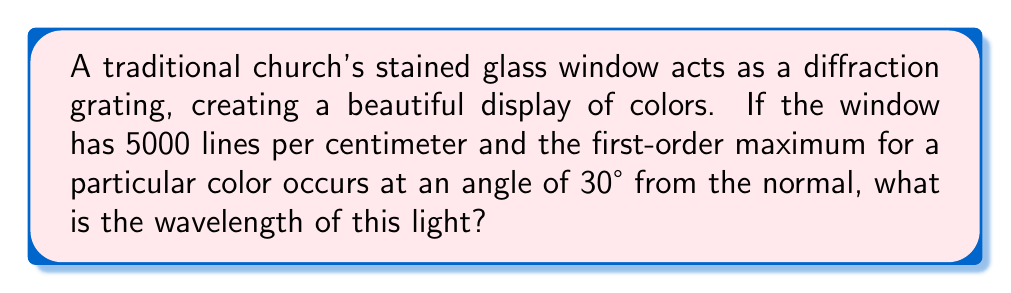Teach me how to tackle this problem. Let's approach this step-by-step using the diffraction grating equation:

1) The diffraction grating equation is:

   $$ d \sin \theta = m \lambda $$

   where:
   $d$ = grating spacing
   $\theta$ = angle of diffraction
   $m$ = order of diffraction (in this case, 1)
   $\lambda$ = wavelength

2) We're given that there are 5000 lines per centimeter. To find $d$, we need to calculate the spacing between lines:

   $$ d = \frac{1 \text{ cm}}{5000} = 2 \times 10^{-4} \text{ cm} = 2000 \text{ nm} $$

3) We're also given that $\theta = 30°$ and $m = 1$.

4) Let's substitute these values into the equation:

   $$ (2000 \text{ nm}) \sin 30° = 1 \lambda $$

5) Simplify:

   $$ 2000 \times 0.5 = \lambda $$

6) Calculate:

   $$ \lambda = 1000 \text{ nm} $$

Thus, the wavelength of the light is 1000 nm or 1 μm.
Answer: 1000 nm 